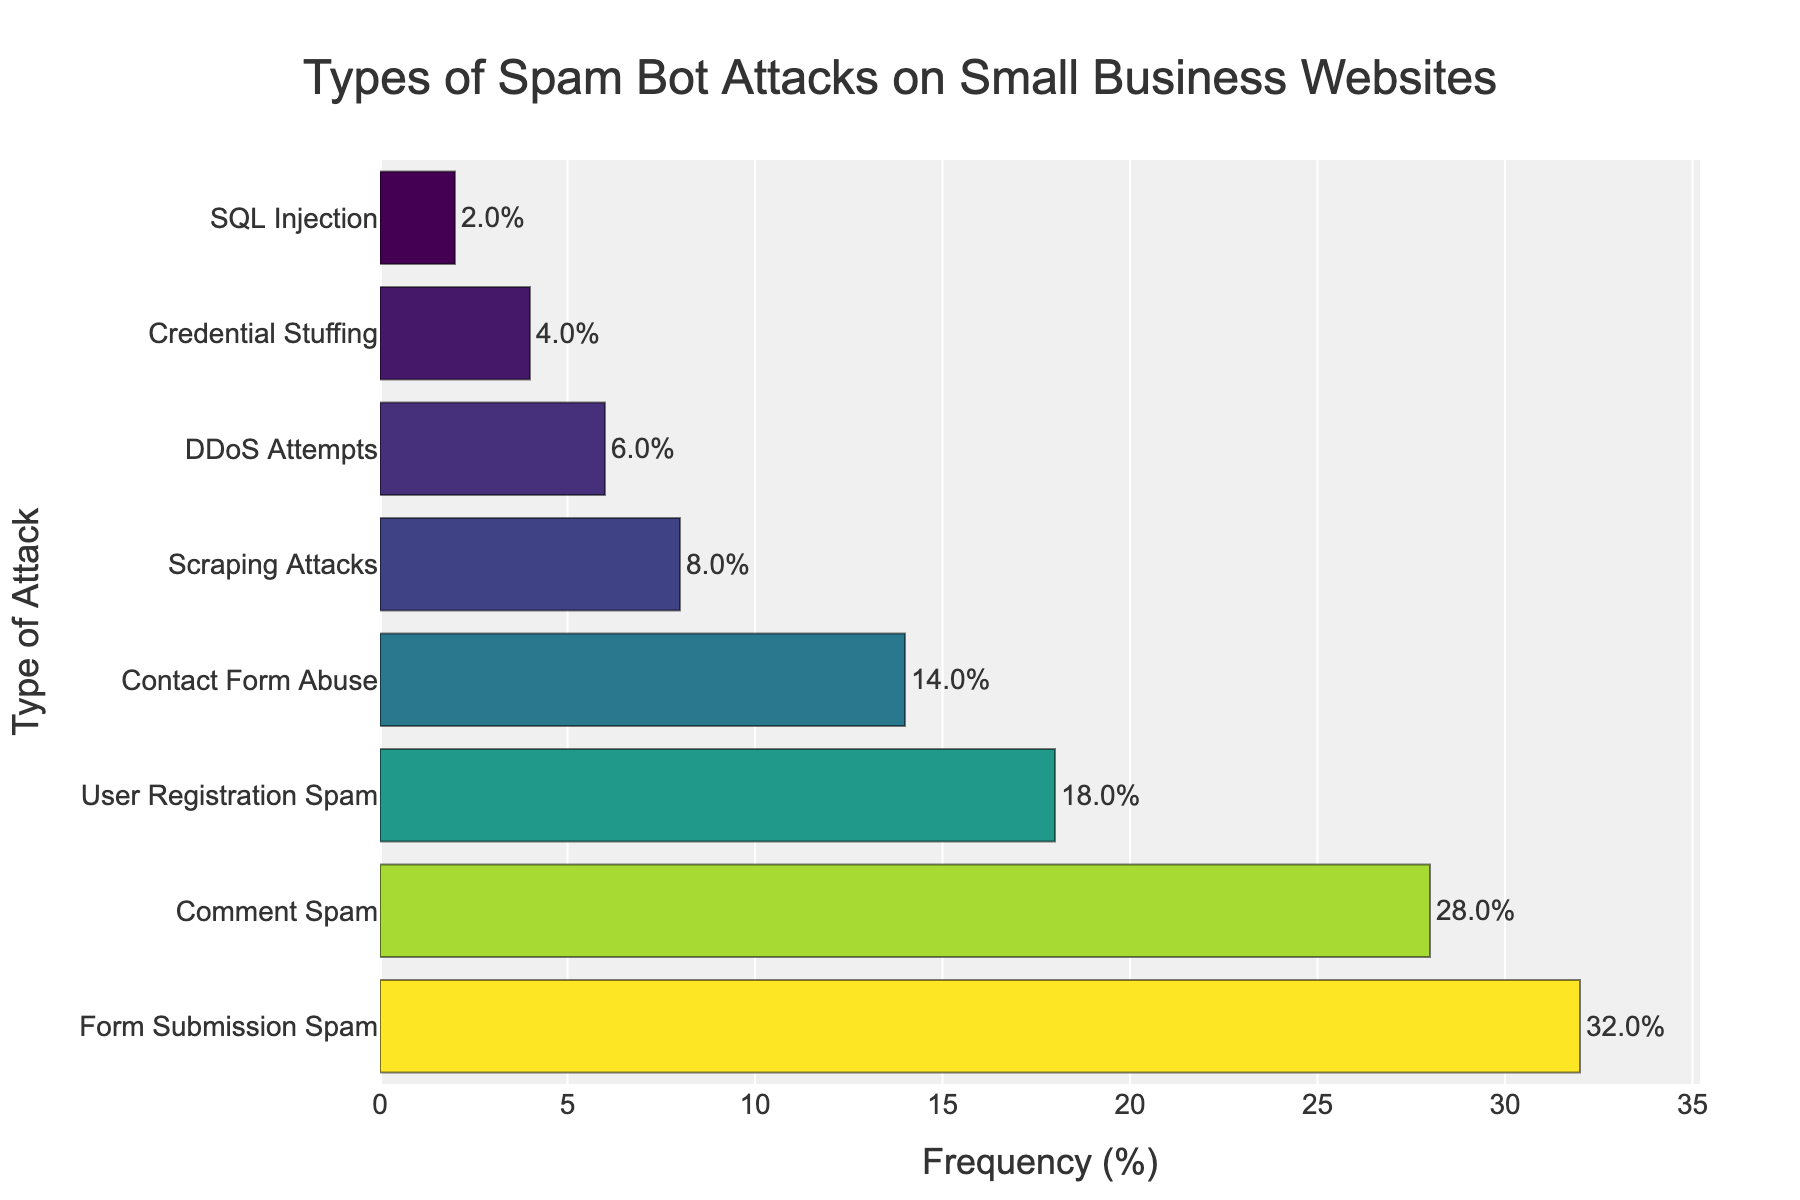What type of spam bot attack is the most common? The figure shows the attack types ordered by frequency, with "Form Submission Spam" having the highest percentage.
Answer: Form Submission Spam Which types of attacks have a frequency greater than 20%? By examining the frequency bars, the types with frequencies above 20% are "Form Submission Spam" and "Comment Spam."
Answer: Form Submission Spam, Comment Spam What is the combined frequency of "User Registration Spam" and "Contact Form Abuse"? Add the frequencies of "User Registration Spam" (18%) and "Contact Form Abuse" (14%). The combined frequency is 18% + 14%.
Answer: 32% Is "SQL Injection" more or less frequent than "DDoS Attempts"? Compare the heights of the bars for "SQL Injection" and "DDoS Attempts." The bar for "DDoS Attempts" is taller, indicating it is more frequent.
Answer: Less frequent How much higher is the frequency of "Scraping Attacks" compared to "SQL Injection"? Subtract the frequency of "SQL Injection" (2%) from that of "Scraping Attacks" (8%).
Answer: 6% Which attack type has the smallest frequency? The shortest bar represents "SQL Injection," with the smallest percentage.
Answer: SQL Injection What is the frequency difference between "Form Submission Spam" and "Comment Spam"? Subtract the frequency of "Comment Spam" (28%) from that of "Form Submission Spam" (32%).
Answer: 4% What is the average frequency of "DDoS Attempts," and "Credential Stuffing"? Add the frequencies of "DDoS Attempts" (6%) and "Credential Stuffing" (4%), then divide by 2 to find the average.
Answer: 5% Which attacks have a frequency below 10%? The bars representing attacks with frequencies below 10% are "Scraping Attacks," "DDoS Attempts," "Credential Stuffing," and "SQL Injection."
Answer: Scraping Attacks, DDoS Attempts, Credential Stuffing, SQL Injection How does the frequency of "User Registration Spam" compare to "Form Submission Spam"? "User Registration Spam" has a frequency of 18%, which is less than the frequency of "Form Submission Spam" at 32%.
Answer: Less frequent 